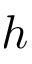Convert formula to latex. <formula><loc_0><loc_0><loc_500><loc_500>h</formula> 